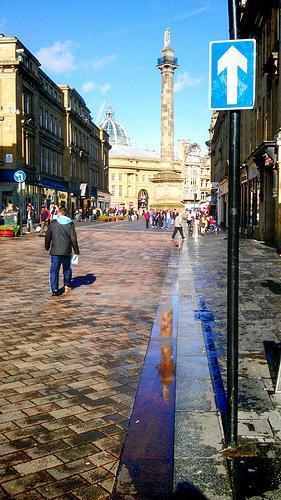How many signs are pictured?
Give a very brief answer. 2. 